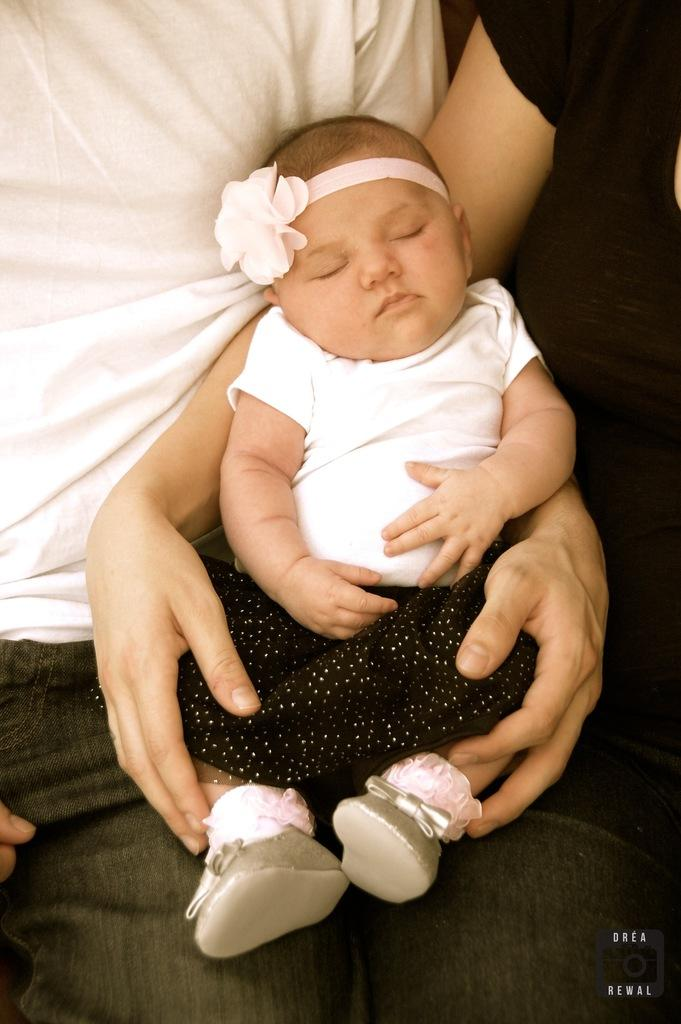How many people are in the image? There are two persons in the image. What are the two persons doing in the image? The two persons are holding a baby. Can you describe any additional features in the image? There is a watermark visible in the image. What type of cellar is visible in the image? There is no cellar present in the image. What is the tendency of the stove in the image? There is no stove present in the image. 